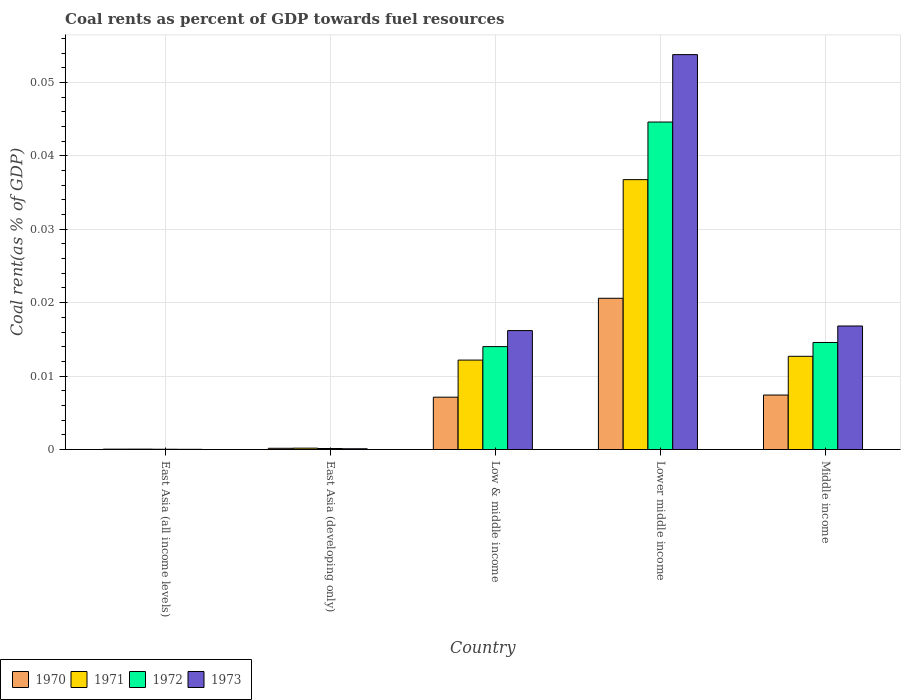How many different coloured bars are there?
Your response must be concise. 4. How many groups of bars are there?
Your answer should be very brief. 5. Are the number of bars on each tick of the X-axis equal?
Offer a terse response. Yes. How many bars are there on the 5th tick from the left?
Provide a short and direct response. 4. How many bars are there on the 5th tick from the right?
Ensure brevity in your answer.  4. What is the label of the 5th group of bars from the left?
Ensure brevity in your answer.  Middle income. What is the coal rent in 1972 in East Asia (all income levels)?
Your response must be concise. 3.67730514806032e-5. Across all countries, what is the maximum coal rent in 1972?
Offer a very short reply. 0.04. Across all countries, what is the minimum coal rent in 1971?
Give a very brief answer. 5.470114168356261e-5. In which country was the coal rent in 1970 maximum?
Your response must be concise. Lower middle income. In which country was the coal rent in 1970 minimum?
Keep it short and to the point. East Asia (all income levels). What is the total coal rent in 1971 in the graph?
Your answer should be very brief. 0.06. What is the difference between the coal rent in 1972 in Lower middle income and that in Middle income?
Give a very brief answer. 0.03. What is the difference between the coal rent in 1973 in Low & middle income and the coal rent in 1971 in East Asia (all income levels)?
Your response must be concise. 0.02. What is the average coal rent in 1970 per country?
Your answer should be compact. 0.01. What is the difference between the coal rent of/in 1971 and coal rent of/in 1972 in East Asia (developing only)?
Your answer should be compact. 4.9569085611083014e-5. In how many countries, is the coal rent in 1971 greater than 0.03 %?
Your answer should be very brief. 1. What is the ratio of the coal rent in 1971 in East Asia (all income levels) to that in Middle income?
Keep it short and to the point. 0. What is the difference between the highest and the second highest coal rent in 1971?
Provide a succinct answer. 0.02. What is the difference between the highest and the lowest coal rent in 1971?
Your answer should be very brief. 0.04. In how many countries, is the coal rent in 1971 greater than the average coal rent in 1971 taken over all countries?
Your answer should be very brief. 2. What does the 2nd bar from the right in Middle income represents?
Offer a very short reply. 1972. Is it the case that in every country, the sum of the coal rent in 1970 and coal rent in 1973 is greater than the coal rent in 1972?
Give a very brief answer. Yes. How many bars are there?
Offer a terse response. 20. Are all the bars in the graph horizontal?
Offer a terse response. No. What is the difference between two consecutive major ticks on the Y-axis?
Your answer should be very brief. 0.01. Does the graph contain any zero values?
Provide a succinct answer. No. Does the graph contain grids?
Ensure brevity in your answer.  Yes. Where does the legend appear in the graph?
Your response must be concise. Bottom left. How many legend labels are there?
Keep it short and to the point. 4. How are the legend labels stacked?
Keep it short and to the point. Horizontal. What is the title of the graph?
Make the answer very short. Coal rents as percent of GDP towards fuel resources. Does "2015" appear as one of the legend labels in the graph?
Your response must be concise. No. What is the label or title of the Y-axis?
Your response must be concise. Coal rent(as % of GDP). What is the Coal rent(as % of GDP) in 1970 in East Asia (all income levels)?
Offer a terse response. 5.1314079013758e-5. What is the Coal rent(as % of GDP) of 1971 in East Asia (all income levels)?
Offer a terse response. 5.470114168356261e-5. What is the Coal rent(as % of GDP) in 1972 in East Asia (all income levels)?
Your response must be concise. 3.67730514806032e-5. What is the Coal rent(as % of GDP) of 1973 in East Asia (all income levels)?
Your response must be concise. 2.64171247686014e-5. What is the Coal rent(as % of GDP) of 1970 in East Asia (developing only)?
Ensure brevity in your answer.  0. What is the Coal rent(as % of GDP) in 1971 in East Asia (developing only)?
Your answer should be compact. 0. What is the Coal rent(as % of GDP) of 1972 in East Asia (developing only)?
Offer a terse response. 0. What is the Coal rent(as % of GDP) of 1973 in East Asia (developing only)?
Ensure brevity in your answer.  0. What is the Coal rent(as % of GDP) of 1970 in Low & middle income?
Your answer should be compact. 0.01. What is the Coal rent(as % of GDP) of 1971 in Low & middle income?
Provide a succinct answer. 0.01. What is the Coal rent(as % of GDP) in 1972 in Low & middle income?
Provide a succinct answer. 0.01. What is the Coal rent(as % of GDP) of 1973 in Low & middle income?
Ensure brevity in your answer.  0.02. What is the Coal rent(as % of GDP) of 1970 in Lower middle income?
Ensure brevity in your answer.  0.02. What is the Coal rent(as % of GDP) of 1971 in Lower middle income?
Your answer should be compact. 0.04. What is the Coal rent(as % of GDP) in 1972 in Lower middle income?
Give a very brief answer. 0.04. What is the Coal rent(as % of GDP) of 1973 in Lower middle income?
Your answer should be very brief. 0.05. What is the Coal rent(as % of GDP) in 1970 in Middle income?
Provide a succinct answer. 0.01. What is the Coal rent(as % of GDP) in 1971 in Middle income?
Make the answer very short. 0.01. What is the Coal rent(as % of GDP) of 1972 in Middle income?
Ensure brevity in your answer.  0.01. What is the Coal rent(as % of GDP) of 1973 in Middle income?
Your answer should be very brief. 0.02. Across all countries, what is the maximum Coal rent(as % of GDP) in 1970?
Provide a succinct answer. 0.02. Across all countries, what is the maximum Coal rent(as % of GDP) in 1971?
Keep it short and to the point. 0.04. Across all countries, what is the maximum Coal rent(as % of GDP) in 1972?
Make the answer very short. 0.04. Across all countries, what is the maximum Coal rent(as % of GDP) in 1973?
Make the answer very short. 0.05. Across all countries, what is the minimum Coal rent(as % of GDP) of 1970?
Keep it short and to the point. 5.1314079013758e-5. Across all countries, what is the minimum Coal rent(as % of GDP) of 1971?
Offer a very short reply. 5.470114168356261e-5. Across all countries, what is the minimum Coal rent(as % of GDP) in 1972?
Your answer should be very brief. 3.67730514806032e-5. Across all countries, what is the minimum Coal rent(as % of GDP) of 1973?
Offer a very short reply. 2.64171247686014e-5. What is the total Coal rent(as % of GDP) of 1970 in the graph?
Offer a very short reply. 0.04. What is the total Coal rent(as % of GDP) in 1971 in the graph?
Ensure brevity in your answer.  0.06. What is the total Coal rent(as % of GDP) of 1972 in the graph?
Give a very brief answer. 0.07. What is the total Coal rent(as % of GDP) of 1973 in the graph?
Your answer should be compact. 0.09. What is the difference between the Coal rent(as % of GDP) in 1970 in East Asia (all income levels) and that in East Asia (developing only)?
Ensure brevity in your answer.  -0. What is the difference between the Coal rent(as % of GDP) in 1971 in East Asia (all income levels) and that in East Asia (developing only)?
Give a very brief answer. -0. What is the difference between the Coal rent(as % of GDP) in 1972 in East Asia (all income levels) and that in East Asia (developing only)?
Ensure brevity in your answer.  -0. What is the difference between the Coal rent(as % of GDP) of 1973 in East Asia (all income levels) and that in East Asia (developing only)?
Make the answer very short. -0. What is the difference between the Coal rent(as % of GDP) of 1970 in East Asia (all income levels) and that in Low & middle income?
Offer a very short reply. -0.01. What is the difference between the Coal rent(as % of GDP) of 1971 in East Asia (all income levels) and that in Low & middle income?
Your answer should be very brief. -0.01. What is the difference between the Coal rent(as % of GDP) in 1972 in East Asia (all income levels) and that in Low & middle income?
Make the answer very short. -0.01. What is the difference between the Coal rent(as % of GDP) in 1973 in East Asia (all income levels) and that in Low & middle income?
Offer a very short reply. -0.02. What is the difference between the Coal rent(as % of GDP) of 1970 in East Asia (all income levels) and that in Lower middle income?
Offer a very short reply. -0.02. What is the difference between the Coal rent(as % of GDP) in 1971 in East Asia (all income levels) and that in Lower middle income?
Make the answer very short. -0.04. What is the difference between the Coal rent(as % of GDP) of 1972 in East Asia (all income levels) and that in Lower middle income?
Make the answer very short. -0.04. What is the difference between the Coal rent(as % of GDP) in 1973 in East Asia (all income levels) and that in Lower middle income?
Your answer should be very brief. -0.05. What is the difference between the Coal rent(as % of GDP) of 1970 in East Asia (all income levels) and that in Middle income?
Provide a short and direct response. -0.01. What is the difference between the Coal rent(as % of GDP) of 1971 in East Asia (all income levels) and that in Middle income?
Your answer should be very brief. -0.01. What is the difference between the Coal rent(as % of GDP) of 1972 in East Asia (all income levels) and that in Middle income?
Offer a very short reply. -0.01. What is the difference between the Coal rent(as % of GDP) in 1973 in East Asia (all income levels) and that in Middle income?
Ensure brevity in your answer.  -0.02. What is the difference between the Coal rent(as % of GDP) of 1970 in East Asia (developing only) and that in Low & middle income?
Your response must be concise. -0.01. What is the difference between the Coal rent(as % of GDP) of 1971 in East Asia (developing only) and that in Low & middle income?
Give a very brief answer. -0.01. What is the difference between the Coal rent(as % of GDP) in 1972 in East Asia (developing only) and that in Low & middle income?
Make the answer very short. -0.01. What is the difference between the Coal rent(as % of GDP) in 1973 in East Asia (developing only) and that in Low & middle income?
Your answer should be compact. -0.02. What is the difference between the Coal rent(as % of GDP) of 1970 in East Asia (developing only) and that in Lower middle income?
Your answer should be compact. -0.02. What is the difference between the Coal rent(as % of GDP) of 1971 in East Asia (developing only) and that in Lower middle income?
Offer a very short reply. -0.04. What is the difference between the Coal rent(as % of GDP) of 1972 in East Asia (developing only) and that in Lower middle income?
Your response must be concise. -0.04. What is the difference between the Coal rent(as % of GDP) in 1973 in East Asia (developing only) and that in Lower middle income?
Keep it short and to the point. -0.05. What is the difference between the Coal rent(as % of GDP) of 1970 in East Asia (developing only) and that in Middle income?
Offer a very short reply. -0.01. What is the difference between the Coal rent(as % of GDP) of 1971 in East Asia (developing only) and that in Middle income?
Offer a terse response. -0.01. What is the difference between the Coal rent(as % of GDP) of 1972 in East Asia (developing only) and that in Middle income?
Your answer should be compact. -0.01. What is the difference between the Coal rent(as % of GDP) of 1973 in East Asia (developing only) and that in Middle income?
Give a very brief answer. -0.02. What is the difference between the Coal rent(as % of GDP) in 1970 in Low & middle income and that in Lower middle income?
Your answer should be very brief. -0.01. What is the difference between the Coal rent(as % of GDP) of 1971 in Low & middle income and that in Lower middle income?
Your answer should be very brief. -0.02. What is the difference between the Coal rent(as % of GDP) of 1972 in Low & middle income and that in Lower middle income?
Your response must be concise. -0.03. What is the difference between the Coal rent(as % of GDP) in 1973 in Low & middle income and that in Lower middle income?
Offer a very short reply. -0.04. What is the difference between the Coal rent(as % of GDP) of 1970 in Low & middle income and that in Middle income?
Your response must be concise. -0. What is the difference between the Coal rent(as % of GDP) of 1971 in Low & middle income and that in Middle income?
Offer a terse response. -0. What is the difference between the Coal rent(as % of GDP) of 1972 in Low & middle income and that in Middle income?
Keep it short and to the point. -0. What is the difference between the Coal rent(as % of GDP) in 1973 in Low & middle income and that in Middle income?
Ensure brevity in your answer.  -0. What is the difference between the Coal rent(as % of GDP) of 1970 in Lower middle income and that in Middle income?
Offer a very short reply. 0.01. What is the difference between the Coal rent(as % of GDP) of 1971 in Lower middle income and that in Middle income?
Your answer should be compact. 0.02. What is the difference between the Coal rent(as % of GDP) in 1972 in Lower middle income and that in Middle income?
Provide a succinct answer. 0.03. What is the difference between the Coal rent(as % of GDP) in 1973 in Lower middle income and that in Middle income?
Ensure brevity in your answer.  0.04. What is the difference between the Coal rent(as % of GDP) in 1970 in East Asia (all income levels) and the Coal rent(as % of GDP) in 1971 in East Asia (developing only)?
Provide a short and direct response. -0. What is the difference between the Coal rent(as % of GDP) of 1970 in East Asia (all income levels) and the Coal rent(as % of GDP) of 1972 in East Asia (developing only)?
Give a very brief answer. -0. What is the difference between the Coal rent(as % of GDP) of 1970 in East Asia (all income levels) and the Coal rent(as % of GDP) of 1973 in East Asia (developing only)?
Your answer should be very brief. -0. What is the difference between the Coal rent(as % of GDP) in 1971 in East Asia (all income levels) and the Coal rent(as % of GDP) in 1972 in East Asia (developing only)?
Your answer should be very brief. -0. What is the difference between the Coal rent(as % of GDP) in 1971 in East Asia (all income levels) and the Coal rent(as % of GDP) in 1973 in East Asia (developing only)?
Provide a short and direct response. -0. What is the difference between the Coal rent(as % of GDP) of 1972 in East Asia (all income levels) and the Coal rent(as % of GDP) of 1973 in East Asia (developing only)?
Your response must be concise. -0. What is the difference between the Coal rent(as % of GDP) in 1970 in East Asia (all income levels) and the Coal rent(as % of GDP) in 1971 in Low & middle income?
Ensure brevity in your answer.  -0.01. What is the difference between the Coal rent(as % of GDP) of 1970 in East Asia (all income levels) and the Coal rent(as % of GDP) of 1972 in Low & middle income?
Your answer should be compact. -0.01. What is the difference between the Coal rent(as % of GDP) of 1970 in East Asia (all income levels) and the Coal rent(as % of GDP) of 1973 in Low & middle income?
Your answer should be very brief. -0.02. What is the difference between the Coal rent(as % of GDP) of 1971 in East Asia (all income levels) and the Coal rent(as % of GDP) of 1972 in Low & middle income?
Keep it short and to the point. -0.01. What is the difference between the Coal rent(as % of GDP) in 1971 in East Asia (all income levels) and the Coal rent(as % of GDP) in 1973 in Low & middle income?
Provide a short and direct response. -0.02. What is the difference between the Coal rent(as % of GDP) of 1972 in East Asia (all income levels) and the Coal rent(as % of GDP) of 1973 in Low & middle income?
Ensure brevity in your answer.  -0.02. What is the difference between the Coal rent(as % of GDP) of 1970 in East Asia (all income levels) and the Coal rent(as % of GDP) of 1971 in Lower middle income?
Make the answer very short. -0.04. What is the difference between the Coal rent(as % of GDP) of 1970 in East Asia (all income levels) and the Coal rent(as % of GDP) of 1972 in Lower middle income?
Your answer should be very brief. -0.04. What is the difference between the Coal rent(as % of GDP) in 1970 in East Asia (all income levels) and the Coal rent(as % of GDP) in 1973 in Lower middle income?
Make the answer very short. -0.05. What is the difference between the Coal rent(as % of GDP) in 1971 in East Asia (all income levels) and the Coal rent(as % of GDP) in 1972 in Lower middle income?
Keep it short and to the point. -0.04. What is the difference between the Coal rent(as % of GDP) in 1971 in East Asia (all income levels) and the Coal rent(as % of GDP) in 1973 in Lower middle income?
Give a very brief answer. -0.05. What is the difference between the Coal rent(as % of GDP) in 1972 in East Asia (all income levels) and the Coal rent(as % of GDP) in 1973 in Lower middle income?
Offer a terse response. -0.05. What is the difference between the Coal rent(as % of GDP) in 1970 in East Asia (all income levels) and the Coal rent(as % of GDP) in 1971 in Middle income?
Keep it short and to the point. -0.01. What is the difference between the Coal rent(as % of GDP) of 1970 in East Asia (all income levels) and the Coal rent(as % of GDP) of 1972 in Middle income?
Make the answer very short. -0.01. What is the difference between the Coal rent(as % of GDP) in 1970 in East Asia (all income levels) and the Coal rent(as % of GDP) in 1973 in Middle income?
Give a very brief answer. -0.02. What is the difference between the Coal rent(as % of GDP) of 1971 in East Asia (all income levels) and the Coal rent(as % of GDP) of 1972 in Middle income?
Keep it short and to the point. -0.01. What is the difference between the Coal rent(as % of GDP) of 1971 in East Asia (all income levels) and the Coal rent(as % of GDP) of 1973 in Middle income?
Give a very brief answer. -0.02. What is the difference between the Coal rent(as % of GDP) in 1972 in East Asia (all income levels) and the Coal rent(as % of GDP) in 1973 in Middle income?
Give a very brief answer. -0.02. What is the difference between the Coal rent(as % of GDP) of 1970 in East Asia (developing only) and the Coal rent(as % of GDP) of 1971 in Low & middle income?
Keep it short and to the point. -0.01. What is the difference between the Coal rent(as % of GDP) of 1970 in East Asia (developing only) and the Coal rent(as % of GDP) of 1972 in Low & middle income?
Give a very brief answer. -0.01. What is the difference between the Coal rent(as % of GDP) of 1970 in East Asia (developing only) and the Coal rent(as % of GDP) of 1973 in Low & middle income?
Provide a succinct answer. -0.02. What is the difference between the Coal rent(as % of GDP) in 1971 in East Asia (developing only) and the Coal rent(as % of GDP) in 1972 in Low & middle income?
Ensure brevity in your answer.  -0.01. What is the difference between the Coal rent(as % of GDP) of 1971 in East Asia (developing only) and the Coal rent(as % of GDP) of 1973 in Low & middle income?
Your answer should be compact. -0.02. What is the difference between the Coal rent(as % of GDP) in 1972 in East Asia (developing only) and the Coal rent(as % of GDP) in 1973 in Low & middle income?
Make the answer very short. -0.02. What is the difference between the Coal rent(as % of GDP) in 1970 in East Asia (developing only) and the Coal rent(as % of GDP) in 1971 in Lower middle income?
Give a very brief answer. -0.04. What is the difference between the Coal rent(as % of GDP) in 1970 in East Asia (developing only) and the Coal rent(as % of GDP) in 1972 in Lower middle income?
Offer a terse response. -0.04. What is the difference between the Coal rent(as % of GDP) in 1970 in East Asia (developing only) and the Coal rent(as % of GDP) in 1973 in Lower middle income?
Make the answer very short. -0.05. What is the difference between the Coal rent(as % of GDP) of 1971 in East Asia (developing only) and the Coal rent(as % of GDP) of 1972 in Lower middle income?
Give a very brief answer. -0.04. What is the difference between the Coal rent(as % of GDP) of 1971 in East Asia (developing only) and the Coal rent(as % of GDP) of 1973 in Lower middle income?
Make the answer very short. -0.05. What is the difference between the Coal rent(as % of GDP) of 1972 in East Asia (developing only) and the Coal rent(as % of GDP) of 1973 in Lower middle income?
Ensure brevity in your answer.  -0.05. What is the difference between the Coal rent(as % of GDP) of 1970 in East Asia (developing only) and the Coal rent(as % of GDP) of 1971 in Middle income?
Offer a terse response. -0.01. What is the difference between the Coal rent(as % of GDP) in 1970 in East Asia (developing only) and the Coal rent(as % of GDP) in 1972 in Middle income?
Offer a terse response. -0.01. What is the difference between the Coal rent(as % of GDP) in 1970 in East Asia (developing only) and the Coal rent(as % of GDP) in 1973 in Middle income?
Ensure brevity in your answer.  -0.02. What is the difference between the Coal rent(as % of GDP) in 1971 in East Asia (developing only) and the Coal rent(as % of GDP) in 1972 in Middle income?
Your answer should be compact. -0.01. What is the difference between the Coal rent(as % of GDP) in 1971 in East Asia (developing only) and the Coal rent(as % of GDP) in 1973 in Middle income?
Keep it short and to the point. -0.02. What is the difference between the Coal rent(as % of GDP) of 1972 in East Asia (developing only) and the Coal rent(as % of GDP) of 1973 in Middle income?
Keep it short and to the point. -0.02. What is the difference between the Coal rent(as % of GDP) in 1970 in Low & middle income and the Coal rent(as % of GDP) in 1971 in Lower middle income?
Provide a succinct answer. -0.03. What is the difference between the Coal rent(as % of GDP) of 1970 in Low & middle income and the Coal rent(as % of GDP) of 1972 in Lower middle income?
Your answer should be very brief. -0.04. What is the difference between the Coal rent(as % of GDP) of 1970 in Low & middle income and the Coal rent(as % of GDP) of 1973 in Lower middle income?
Provide a succinct answer. -0.05. What is the difference between the Coal rent(as % of GDP) of 1971 in Low & middle income and the Coal rent(as % of GDP) of 1972 in Lower middle income?
Give a very brief answer. -0.03. What is the difference between the Coal rent(as % of GDP) of 1971 in Low & middle income and the Coal rent(as % of GDP) of 1973 in Lower middle income?
Make the answer very short. -0.04. What is the difference between the Coal rent(as % of GDP) of 1972 in Low & middle income and the Coal rent(as % of GDP) of 1973 in Lower middle income?
Your answer should be very brief. -0.04. What is the difference between the Coal rent(as % of GDP) of 1970 in Low & middle income and the Coal rent(as % of GDP) of 1971 in Middle income?
Your answer should be compact. -0.01. What is the difference between the Coal rent(as % of GDP) in 1970 in Low & middle income and the Coal rent(as % of GDP) in 1972 in Middle income?
Keep it short and to the point. -0.01. What is the difference between the Coal rent(as % of GDP) of 1970 in Low & middle income and the Coal rent(as % of GDP) of 1973 in Middle income?
Offer a terse response. -0.01. What is the difference between the Coal rent(as % of GDP) in 1971 in Low & middle income and the Coal rent(as % of GDP) in 1972 in Middle income?
Your response must be concise. -0. What is the difference between the Coal rent(as % of GDP) in 1971 in Low & middle income and the Coal rent(as % of GDP) in 1973 in Middle income?
Ensure brevity in your answer.  -0. What is the difference between the Coal rent(as % of GDP) in 1972 in Low & middle income and the Coal rent(as % of GDP) in 1973 in Middle income?
Make the answer very short. -0. What is the difference between the Coal rent(as % of GDP) in 1970 in Lower middle income and the Coal rent(as % of GDP) in 1971 in Middle income?
Keep it short and to the point. 0.01. What is the difference between the Coal rent(as % of GDP) of 1970 in Lower middle income and the Coal rent(as % of GDP) of 1972 in Middle income?
Give a very brief answer. 0.01. What is the difference between the Coal rent(as % of GDP) of 1970 in Lower middle income and the Coal rent(as % of GDP) of 1973 in Middle income?
Your answer should be very brief. 0. What is the difference between the Coal rent(as % of GDP) of 1971 in Lower middle income and the Coal rent(as % of GDP) of 1972 in Middle income?
Your answer should be very brief. 0.02. What is the difference between the Coal rent(as % of GDP) in 1971 in Lower middle income and the Coal rent(as % of GDP) in 1973 in Middle income?
Offer a very short reply. 0.02. What is the difference between the Coal rent(as % of GDP) in 1972 in Lower middle income and the Coal rent(as % of GDP) in 1973 in Middle income?
Your answer should be very brief. 0.03. What is the average Coal rent(as % of GDP) of 1970 per country?
Your response must be concise. 0.01. What is the average Coal rent(as % of GDP) in 1971 per country?
Provide a short and direct response. 0.01. What is the average Coal rent(as % of GDP) of 1972 per country?
Provide a succinct answer. 0.01. What is the average Coal rent(as % of GDP) of 1973 per country?
Your response must be concise. 0.02. What is the difference between the Coal rent(as % of GDP) in 1970 and Coal rent(as % of GDP) in 1972 in East Asia (all income levels)?
Ensure brevity in your answer.  0. What is the difference between the Coal rent(as % of GDP) in 1970 and Coal rent(as % of GDP) in 1973 in East Asia (all income levels)?
Provide a short and direct response. 0. What is the difference between the Coal rent(as % of GDP) of 1971 and Coal rent(as % of GDP) of 1973 in East Asia (all income levels)?
Make the answer very short. 0. What is the difference between the Coal rent(as % of GDP) of 1970 and Coal rent(as % of GDP) of 1971 in East Asia (developing only)?
Provide a short and direct response. -0. What is the difference between the Coal rent(as % of GDP) in 1970 and Coal rent(as % of GDP) in 1972 in East Asia (developing only)?
Provide a short and direct response. 0. What is the difference between the Coal rent(as % of GDP) in 1970 and Coal rent(as % of GDP) in 1973 in East Asia (developing only)?
Keep it short and to the point. 0. What is the difference between the Coal rent(as % of GDP) in 1971 and Coal rent(as % of GDP) in 1973 in East Asia (developing only)?
Provide a succinct answer. 0. What is the difference between the Coal rent(as % of GDP) in 1972 and Coal rent(as % of GDP) in 1973 in East Asia (developing only)?
Ensure brevity in your answer.  0. What is the difference between the Coal rent(as % of GDP) of 1970 and Coal rent(as % of GDP) of 1971 in Low & middle income?
Your response must be concise. -0.01. What is the difference between the Coal rent(as % of GDP) in 1970 and Coal rent(as % of GDP) in 1972 in Low & middle income?
Keep it short and to the point. -0.01. What is the difference between the Coal rent(as % of GDP) in 1970 and Coal rent(as % of GDP) in 1973 in Low & middle income?
Ensure brevity in your answer.  -0.01. What is the difference between the Coal rent(as % of GDP) in 1971 and Coal rent(as % of GDP) in 1972 in Low & middle income?
Offer a terse response. -0. What is the difference between the Coal rent(as % of GDP) of 1971 and Coal rent(as % of GDP) of 1973 in Low & middle income?
Make the answer very short. -0. What is the difference between the Coal rent(as % of GDP) in 1972 and Coal rent(as % of GDP) in 1973 in Low & middle income?
Offer a very short reply. -0. What is the difference between the Coal rent(as % of GDP) in 1970 and Coal rent(as % of GDP) in 1971 in Lower middle income?
Give a very brief answer. -0.02. What is the difference between the Coal rent(as % of GDP) of 1970 and Coal rent(as % of GDP) of 1972 in Lower middle income?
Offer a terse response. -0.02. What is the difference between the Coal rent(as % of GDP) of 1970 and Coal rent(as % of GDP) of 1973 in Lower middle income?
Give a very brief answer. -0.03. What is the difference between the Coal rent(as % of GDP) in 1971 and Coal rent(as % of GDP) in 1972 in Lower middle income?
Your answer should be very brief. -0.01. What is the difference between the Coal rent(as % of GDP) in 1971 and Coal rent(as % of GDP) in 1973 in Lower middle income?
Your response must be concise. -0.02. What is the difference between the Coal rent(as % of GDP) of 1972 and Coal rent(as % of GDP) of 1973 in Lower middle income?
Keep it short and to the point. -0.01. What is the difference between the Coal rent(as % of GDP) in 1970 and Coal rent(as % of GDP) in 1971 in Middle income?
Ensure brevity in your answer.  -0.01. What is the difference between the Coal rent(as % of GDP) of 1970 and Coal rent(as % of GDP) of 1972 in Middle income?
Your answer should be very brief. -0.01. What is the difference between the Coal rent(as % of GDP) in 1970 and Coal rent(as % of GDP) in 1973 in Middle income?
Keep it short and to the point. -0.01. What is the difference between the Coal rent(as % of GDP) of 1971 and Coal rent(as % of GDP) of 1972 in Middle income?
Keep it short and to the point. -0. What is the difference between the Coal rent(as % of GDP) of 1971 and Coal rent(as % of GDP) of 1973 in Middle income?
Your answer should be compact. -0. What is the difference between the Coal rent(as % of GDP) in 1972 and Coal rent(as % of GDP) in 1973 in Middle income?
Give a very brief answer. -0. What is the ratio of the Coal rent(as % of GDP) in 1970 in East Asia (all income levels) to that in East Asia (developing only)?
Provide a short and direct response. 0.31. What is the ratio of the Coal rent(as % of GDP) of 1971 in East Asia (all income levels) to that in East Asia (developing only)?
Make the answer very short. 0.29. What is the ratio of the Coal rent(as % of GDP) of 1972 in East Asia (all income levels) to that in East Asia (developing only)?
Your answer should be compact. 0.27. What is the ratio of the Coal rent(as % of GDP) in 1973 in East Asia (all income levels) to that in East Asia (developing only)?
Offer a very short reply. 0.26. What is the ratio of the Coal rent(as % of GDP) in 1970 in East Asia (all income levels) to that in Low & middle income?
Offer a terse response. 0.01. What is the ratio of the Coal rent(as % of GDP) in 1971 in East Asia (all income levels) to that in Low & middle income?
Make the answer very short. 0. What is the ratio of the Coal rent(as % of GDP) of 1972 in East Asia (all income levels) to that in Low & middle income?
Offer a very short reply. 0. What is the ratio of the Coal rent(as % of GDP) in 1973 in East Asia (all income levels) to that in Low & middle income?
Ensure brevity in your answer.  0. What is the ratio of the Coal rent(as % of GDP) of 1970 in East Asia (all income levels) to that in Lower middle income?
Your answer should be compact. 0. What is the ratio of the Coal rent(as % of GDP) of 1971 in East Asia (all income levels) to that in Lower middle income?
Give a very brief answer. 0. What is the ratio of the Coal rent(as % of GDP) of 1972 in East Asia (all income levels) to that in Lower middle income?
Your answer should be very brief. 0. What is the ratio of the Coal rent(as % of GDP) of 1970 in East Asia (all income levels) to that in Middle income?
Your response must be concise. 0.01. What is the ratio of the Coal rent(as % of GDP) of 1971 in East Asia (all income levels) to that in Middle income?
Make the answer very short. 0. What is the ratio of the Coal rent(as % of GDP) of 1972 in East Asia (all income levels) to that in Middle income?
Provide a short and direct response. 0. What is the ratio of the Coal rent(as % of GDP) of 1973 in East Asia (all income levels) to that in Middle income?
Make the answer very short. 0. What is the ratio of the Coal rent(as % of GDP) in 1970 in East Asia (developing only) to that in Low & middle income?
Make the answer very short. 0.02. What is the ratio of the Coal rent(as % of GDP) in 1971 in East Asia (developing only) to that in Low & middle income?
Keep it short and to the point. 0.02. What is the ratio of the Coal rent(as % of GDP) of 1972 in East Asia (developing only) to that in Low & middle income?
Offer a terse response. 0.01. What is the ratio of the Coal rent(as % of GDP) in 1973 in East Asia (developing only) to that in Low & middle income?
Provide a short and direct response. 0.01. What is the ratio of the Coal rent(as % of GDP) in 1970 in East Asia (developing only) to that in Lower middle income?
Offer a terse response. 0.01. What is the ratio of the Coal rent(as % of GDP) in 1971 in East Asia (developing only) to that in Lower middle income?
Offer a very short reply. 0.01. What is the ratio of the Coal rent(as % of GDP) in 1972 in East Asia (developing only) to that in Lower middle income?
Your answer should be compact. 0. What is the ratio of the Coal rent(as % of GDP) of 1973 in East Asia (developing only) to that in Lower middle income?
Your answer should be compact. 0. What is the ratio of the Coal rent(as % of GDP) in 1970 in East Asia (developing only) to that in Middle income?
Offer a terse response. 0.02. What is the ratio of the Coal rent(as % of GDP) of 1971 in East Asia (developing only) to that in Middle income?
Your answer should be very brief. 0.01. What is the ratio of the Coal rent(as % of GDP) of 1972 in East Asia (developing only) to that in Middle income?
Ensure brevity in your answer.  0.01. What is the ratio of the Coal rent(as % of GDP) in 1973 in East Asia (developing only) to that in Middle income?
Ensure brevity in your answer.  0.01. What is the ratio of the Coal rent(as % of GDP) of 1970 in Low & middle income to that in Lower middle income?
Provide a succinct answer. 0.35. What is the ratio of the Coal rent(as % of GDP) of 1971 in Low & middle income to that in Lower middle income?
Give a very brief answer. 0.33. What is the ratio of the Coal rent(as % of GDP) of 1972 in Low & middle income to that in Lower middle income?
Provide a short and direct response. 0.31. What is the ratio of the Coal rent(as % of GDP) of 1973 in Low & middle income to that in Lower middle income?
Your response must be concise. 0.3. What is the ratio of the Coal rent(as % of GDP) in 1970 in Low & middle income to that in Middle income?
Offer a terse response. 0.96. What is the ratio of the Coal rent(as % of GDP) in 1971 in Low & middle income to that in Middle income?
Your response must be concise. 0.96. What is the ratio of the Coal rent(as % of GDP) in 1972 in Low & middle income to that in Middle income?
Offer a terse response. 0.96. What is the ratio of the Coal rent(as % of GDP) of 1973 in Low & middle income to that in Middle income?
Give a very brief answer. 0.96. What is the ratio of the Coal rent(as % of GDP) of 1970 in Lower middle income to that in Middle income?
Make the answer very short. 2.78. What is the ratio of the Coal rent(as % of GDP) in 1971 in Lower middle income to that in Middle income?
Your answer should be very brief. 2.9. What is the ratio of the Coal rent(as % of GDP) of 1972 in Lower middle income to that in Middle income?
Offer a very short reply. 3.06. What is the ratio of the Coal rent(as % of GDP) of 1973 in Lower middle income to that in Middle income?
Your response must be concise. 3.2. What is the difference between the highest and the second highest Coal rent(as % of GDP) in 1970?
Make the answer very short. 0.01. What is the difference between the highest and the second highest Coal rent(as % of GDP) in 1971?
Offer a very short reply. 0.02. What is the difference between the highest and the second highest Coal rent(as % of GDP) of 1973?
Your response must be concise. 0.04. What is the difference between the highest and the lowest Coal rent(as % of GDP) of 1970?
Your response must be concise. 0.02. What is the difference between the highest and the lowest Coal rent(as % of GDP) of 1971?
Your answer should be compact. 0.04. What is the difference between the highest and the lowest Coal rent(as % of GDP) of 1972?
Offer a terse response. 0.04. What is the difference between the highest and the lowest Coal rent(as % of GDP) of 1973?
Provide a short and direct response. 0.05. 